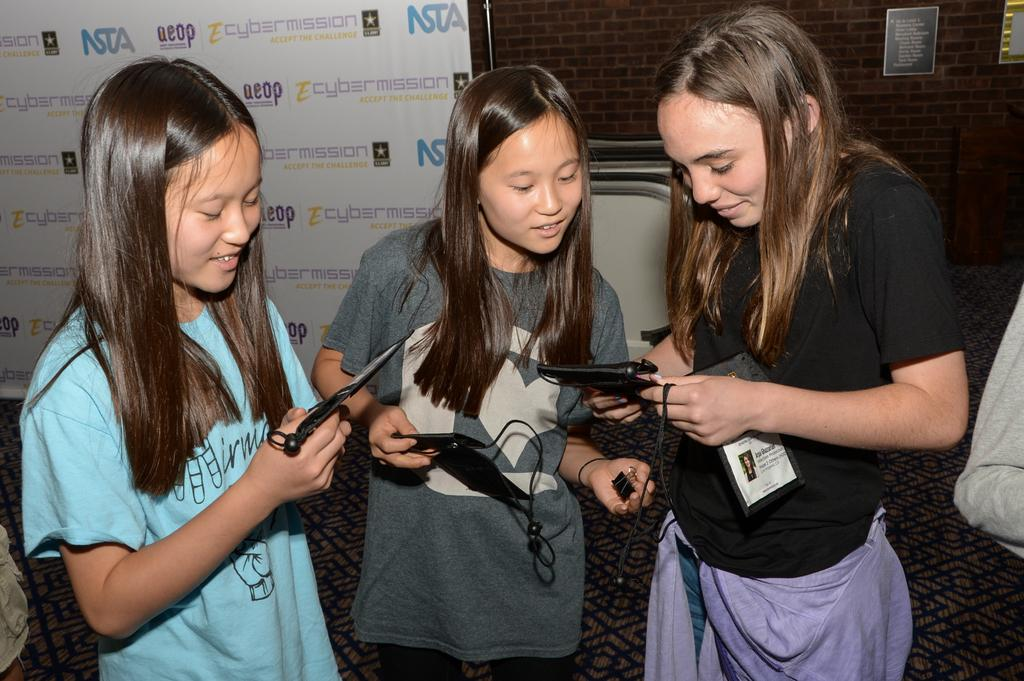Who is present in the image? There are women in the image. What are the women doing in the image? The women are standing and holding mobiles. What can be seen in the background of the image? There is a banner on a wall in the background of the image. What type of base is supporting the goldfish in the image? There are no goldfish present in the image, so there is no base supporting them. 